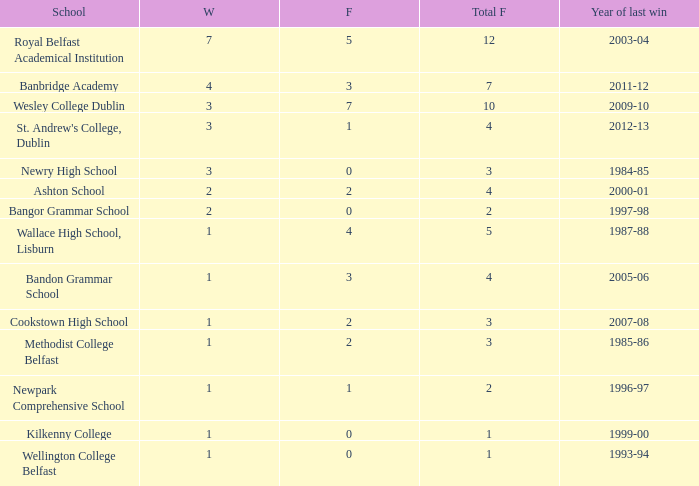How many total finals where there when the last win was in 2012-13? 4.0. 